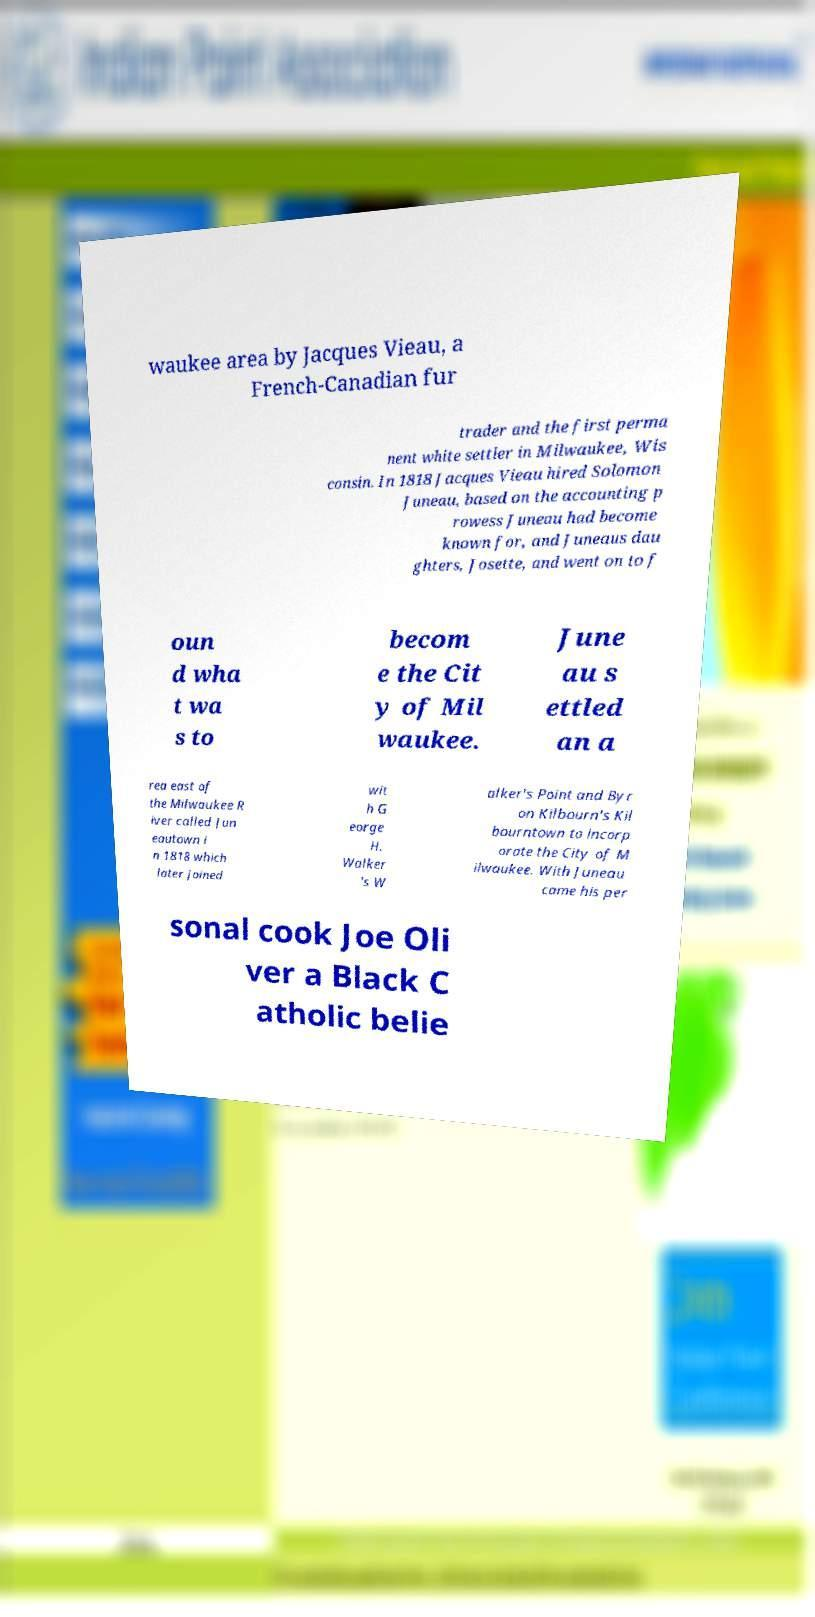I need the written content from this picture converted into text. Can you do that? waukee area by Jacques Vieau, a French-Canadian fur trader and the first perma nent white settler in Milwaukee, Wis consin. In 1818 Jacques Vieau hired Solomon Juneau, based on the accounting p rowess Juneau had become known for, and Juneaus dau ghters, Josette, and went on to f oun d wha t wa s to becom e the Cit y of Mil waukee. June au s ettled an a rea east of the Milwaukee R iver called Jun eautown i n 1818 which later joined wit h G eorge H. Walker 's W alker's Point and Byr on Kilbourn's Kil bourntown to incorp orate the City of M ilwaukee. With Juneau came his per sonal cook Joe Oli ver a Black C atholic belie 